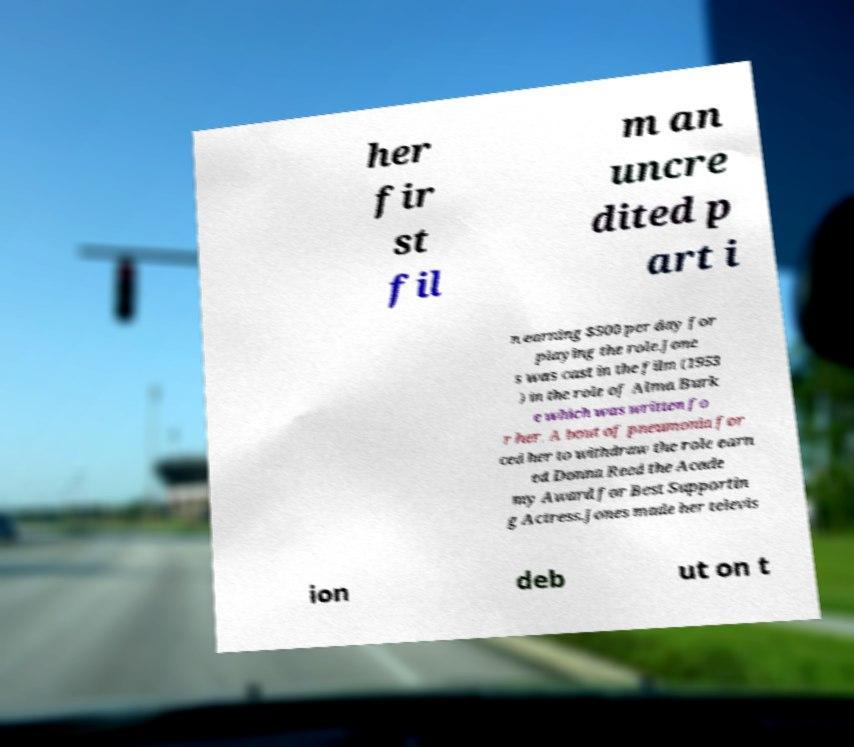Could you assist in decoding the text presented in this image and type it out clearly? her fir st fil m an uncre dited p art i n earning $500 per day for playing the role.Jone s was cast in the film (1953 ) in the role of Alma Burk e which was written fo r her. A bout of pneumonia for ced her to withdraw the role earn ed Donna Reed the Acade my Award for Best Supportin g Actress.Jones made her televis ion deb ut on t 